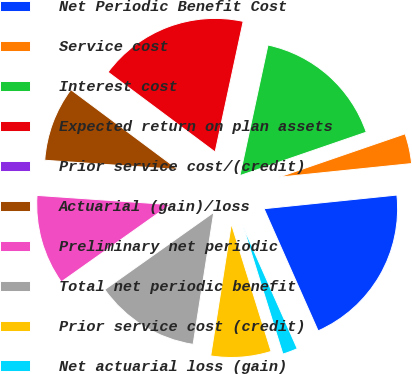<chart> <loc_0><loc_0><loc_500><loc_500><pie_chart><fcel>Net Periodic Benefit Cost<fcel>Service cost<fcel>Interest cost<fcel>Expected return on plan assets<fcel>Prior service cost/(credit)<fcel>Actuarial (gain)/loss<fcel>Preliminary net periodic<fcel>Total net periodic benefit<fcel>Prior service cost (credit)<fcel>Net actuarial loss (gain)<nl><fcel>19.99%<fcel>3.64%<fcel>16.36%<fcel>18.17%<fcel>0.01%<fcel>9.09%<fcel>10.91%<fcel>12.72%<fcel>7.28%<fcel>1.83%<nl></chart> 